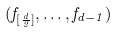Convert formula to latex. <formula><loc_0><loc_0><loc_500><loc_500>( f _ { [ \frac { d } { 2 } ] } , \dots , f _ { d - 1 } )</formula> 